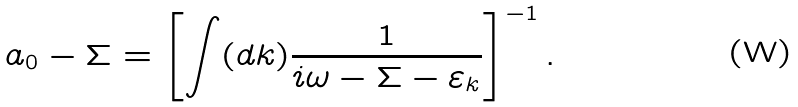Convert formula to latex. <formula><loc_0><loc_0><loc_500><loc_500>a _ { 0 } - \Sigma = \left [ \int ( d k ) \frac { 1 } { i \omega - \Sigma - \varepsilon _ { k } } \right ] ^ { - 1 } .</formula> 